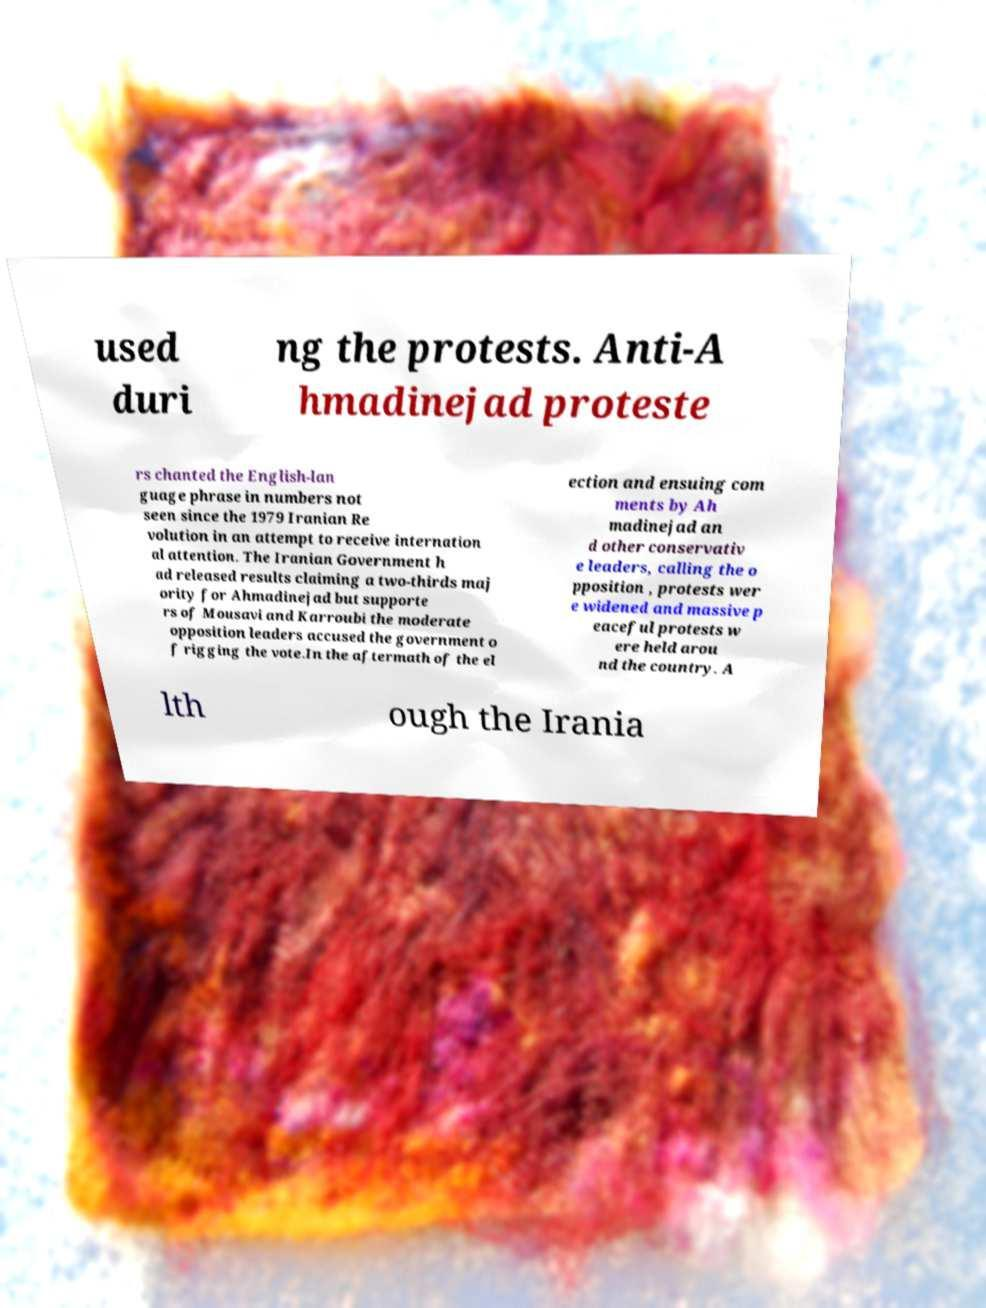I need the written content from this picture converted into text. Can you do that? used duri ng the protests. Anti-A hmadinejad proteste rs chanted the English-lan guage phrase in numbers not seen since the 1979 Iranian Re volution in an attempt to receive internation al attention. The Iranian Government h ad released results claiming a two-thirds maj ority for Ahmadinejad but supporte rs of Mousavi and Karroubi the moderate opposition leaders accused the government o f rigging the vote.In the aftermath of the el ection and ensuing com ments by Ah madinejad an d other conservativ e leaders, calling the o pposition , protests wer e widened and massive p eaceful protests w ere held arou nd the country. A lth ough the Irania 